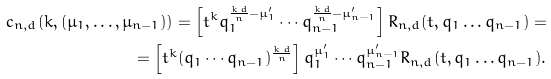<formula> <loc_0><loc_0><loc_500><loc_500>c _ { n , d } ( k , ( \mu _ { 1 } , \dots , \mu _ { n - 1 } ) ) = \left [ t ^ { k } q _ { 1 } ^ { \frac { k \, d } { n } - \mu _ { 1 } ^ { \prime } } \cdots q _ { n - 1 } ^ { \frac { k \, d } { n } - \mu _ { n - 1 } ^ { \prime } } \right ] R _ { n , d } ( t , q _ { 1 } \dots q _ { n - 1 } ) = \\ = \left [ t ^ { k } ( q _ { 1 } \cdots q _ { n - 1 } ) ^ { \frac { k \, d } { n } } \right ] q _ { 1 } ^ { \mu ^ { \prime } _ { 1 } } \cdots q _ { n - 1 } ^ { \mu _ { n - 1 } ^ { \prime } } R _ { n , d } ( t , q _ { 1 } \dots q _ { n - 1 } ) .</formula> 